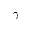Convert formula to latex. <formula><loc_0><loc_0><loc_500><loc_500>\gamma</formula> 